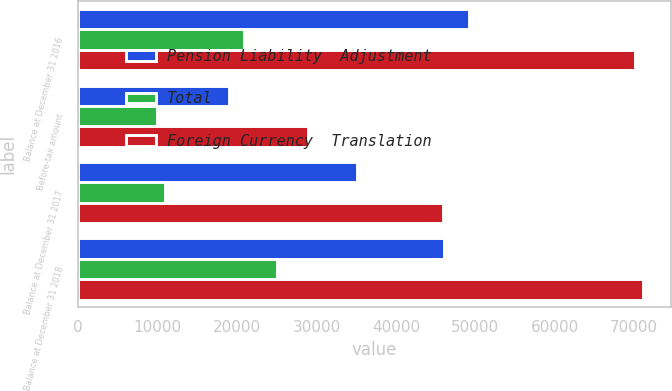Convert chart to OTSL. <chart><loc_0><loc_0><loc_500><loc_500><stacked_bar_chart><ecel><fcel>Balance at December 31 2016<fcel>Before-tax amount<fcel>Balance at December 31 2017<fcel>Balance at December 31 2018<nl><fcel>Pension Liability  Adjustment<fcel>49200<fcel>18980<fcel>35041<fcel>46091<nl><fcel>Total<fcel>20875<fcel>9960<fcel>10915<fcel>24987<nl><fcel>Foreign Currency  Translation<fcel>70075<fcel>28940<fcel>45956<fcel>71078<nl></chart> 